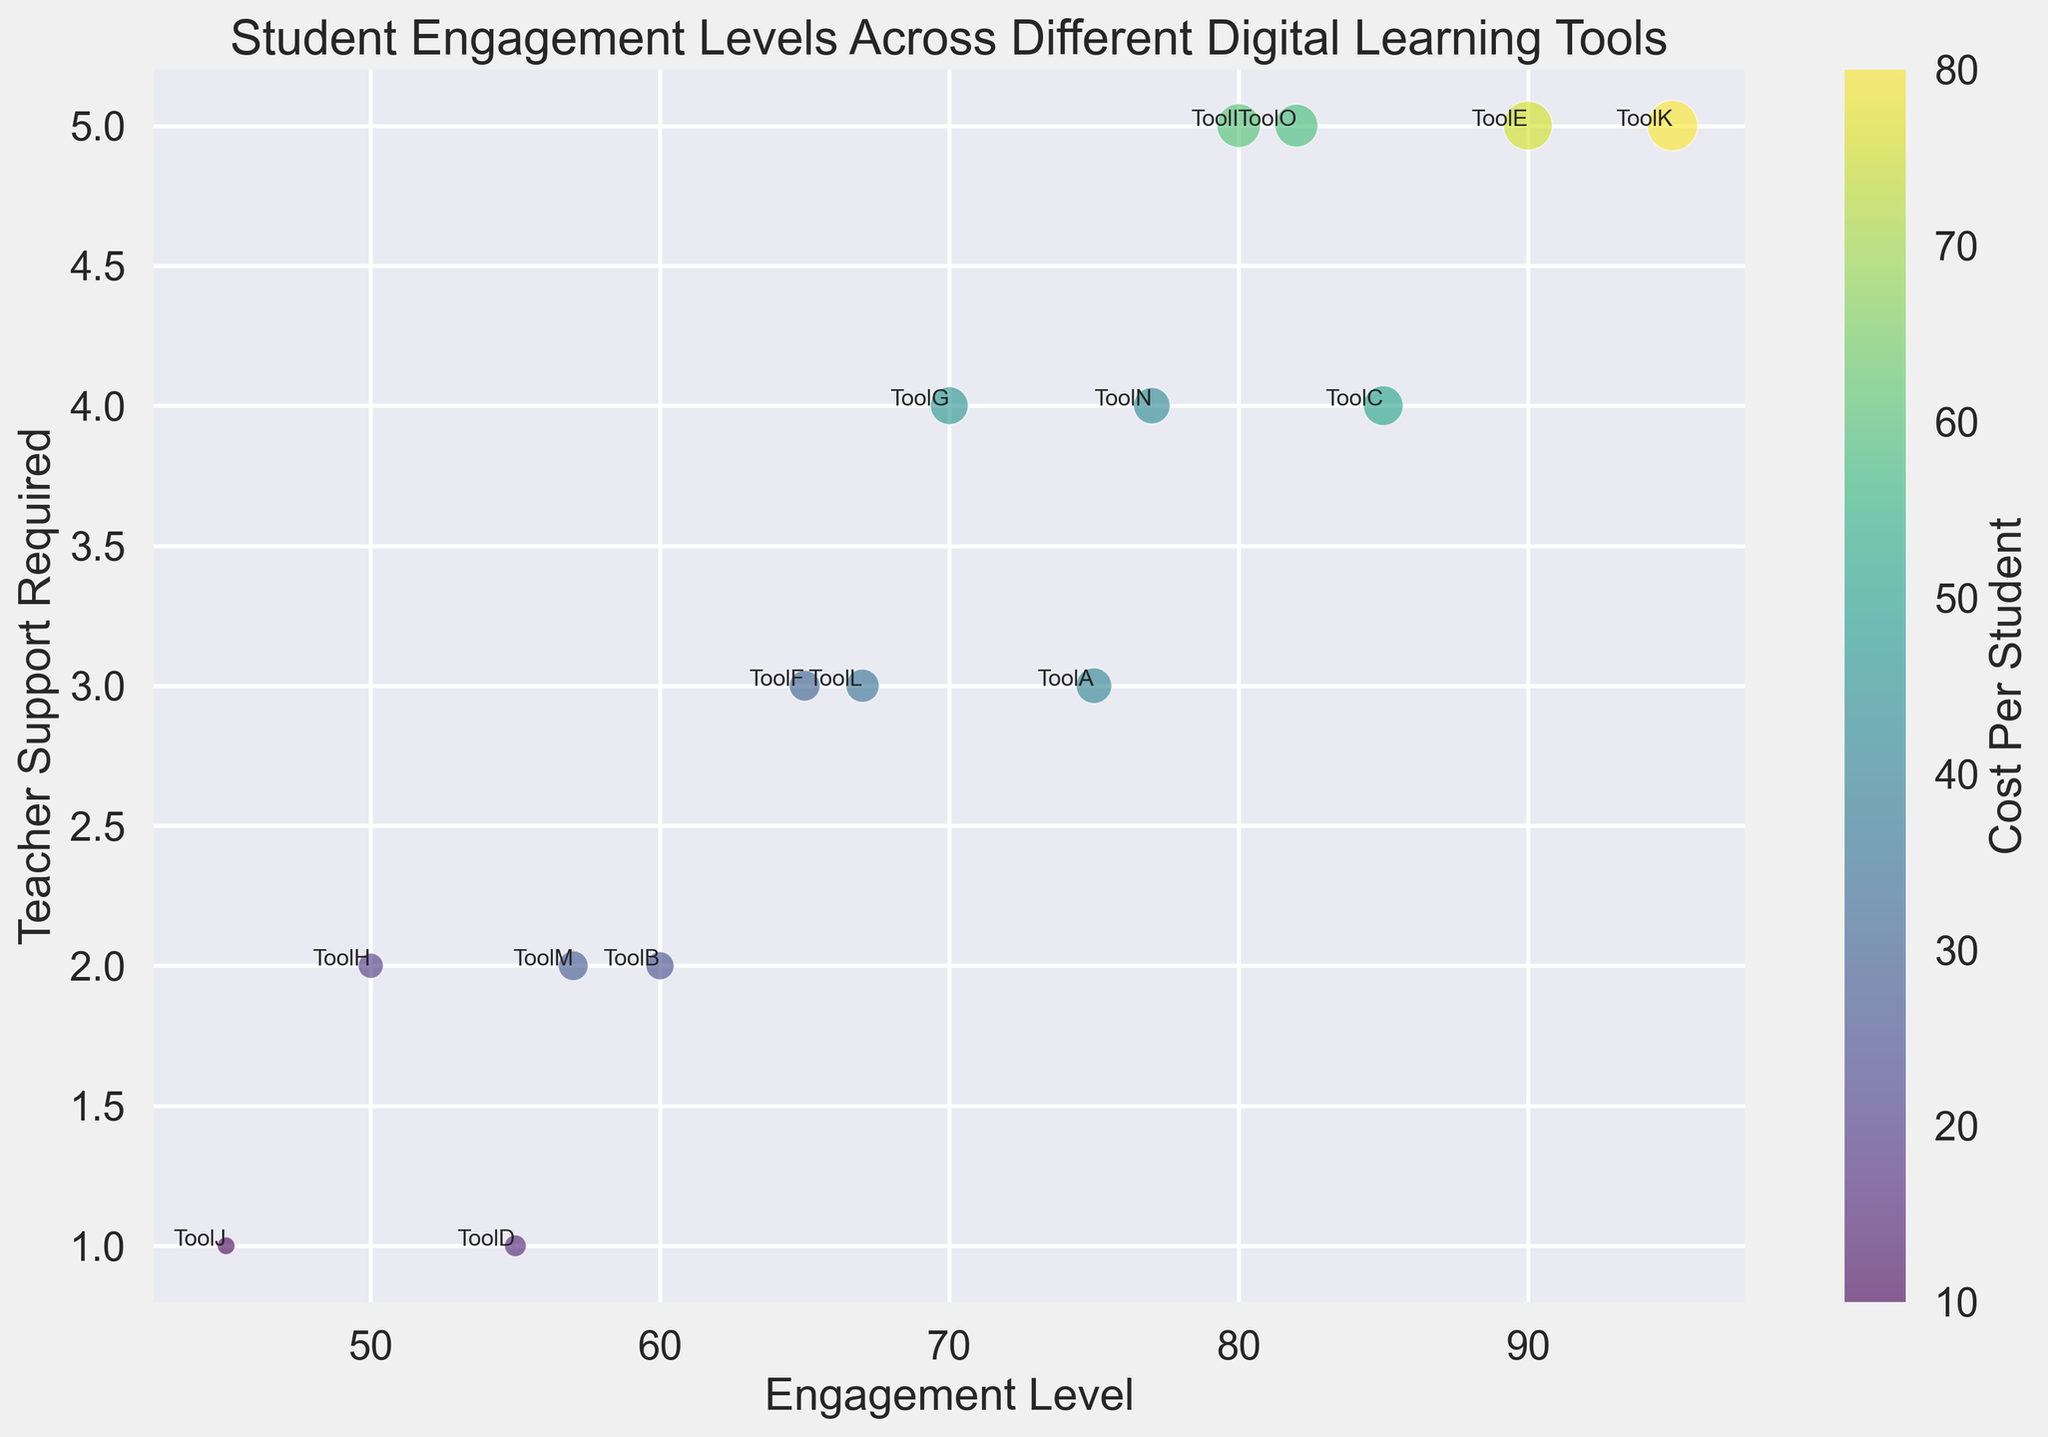What tool requires the most teacher support? The tool that requires the most teacher support can be identified by looking at the data point with the highest value on the y-axis.
Answer: ToolE Which tool has the highest student engagement level? The tool with the highest student engagement level is found by locating the data point with the highest value on the x-axis.
Answer: ToolK Which tool has the lowest cost per student? The tool with the lowest cost per student can be found by identifying the smallest-sized bubble in the scatter plot.
Answer: ToolJ What is the difference in teacher support required between ToolA and ToolD? The teacher support required for ToolA is 3 and for ToolD is 1. The difference is calculated as 3 - 1.
Answer: 2 Which has a higher engagement level, ToolG or ToolN? ToolG has an engagement level of 70, while ToolN has an engagement level of 77. Comparing these values, ToolN has a higher engagement level.
Answer: ToolN What is the average cost per student for ToolB and ToolH? The cost per student for ToolB is 25 and for ToolH is 20. The average cost is calculated as (25 + 20) / 2.
Answer: 22.5 What is the range of engagement levels across all tools? The range is calculated by identifying the highest and lowest engagement levels, which are 95 for ToolK and 45 for ToolJ, respectively. The range is 95 - 45.
Answer: 50 Which tool with an engagement level above 80 requires the least teacher support? Tools with an engagement level above 80 are ToolC, ToolI, and ToolO. Among these, the one requiring the least teacher support has the lowest value on the y-axis.
Answer: ToolI Between ToolM and ToolF, which tool is more costly? The cost per student for ToolM is 28, and for ToolF, it is 30. ToolF is more costly as it has a higher value.
Answer: ToolF Does ToolC or ToolG have a higher cost per student, and by how much? ToolC's cost per student is 50 and ToolG's is 45. The difference is calculated as 50 - 45.
Answer: ToolC by 5 